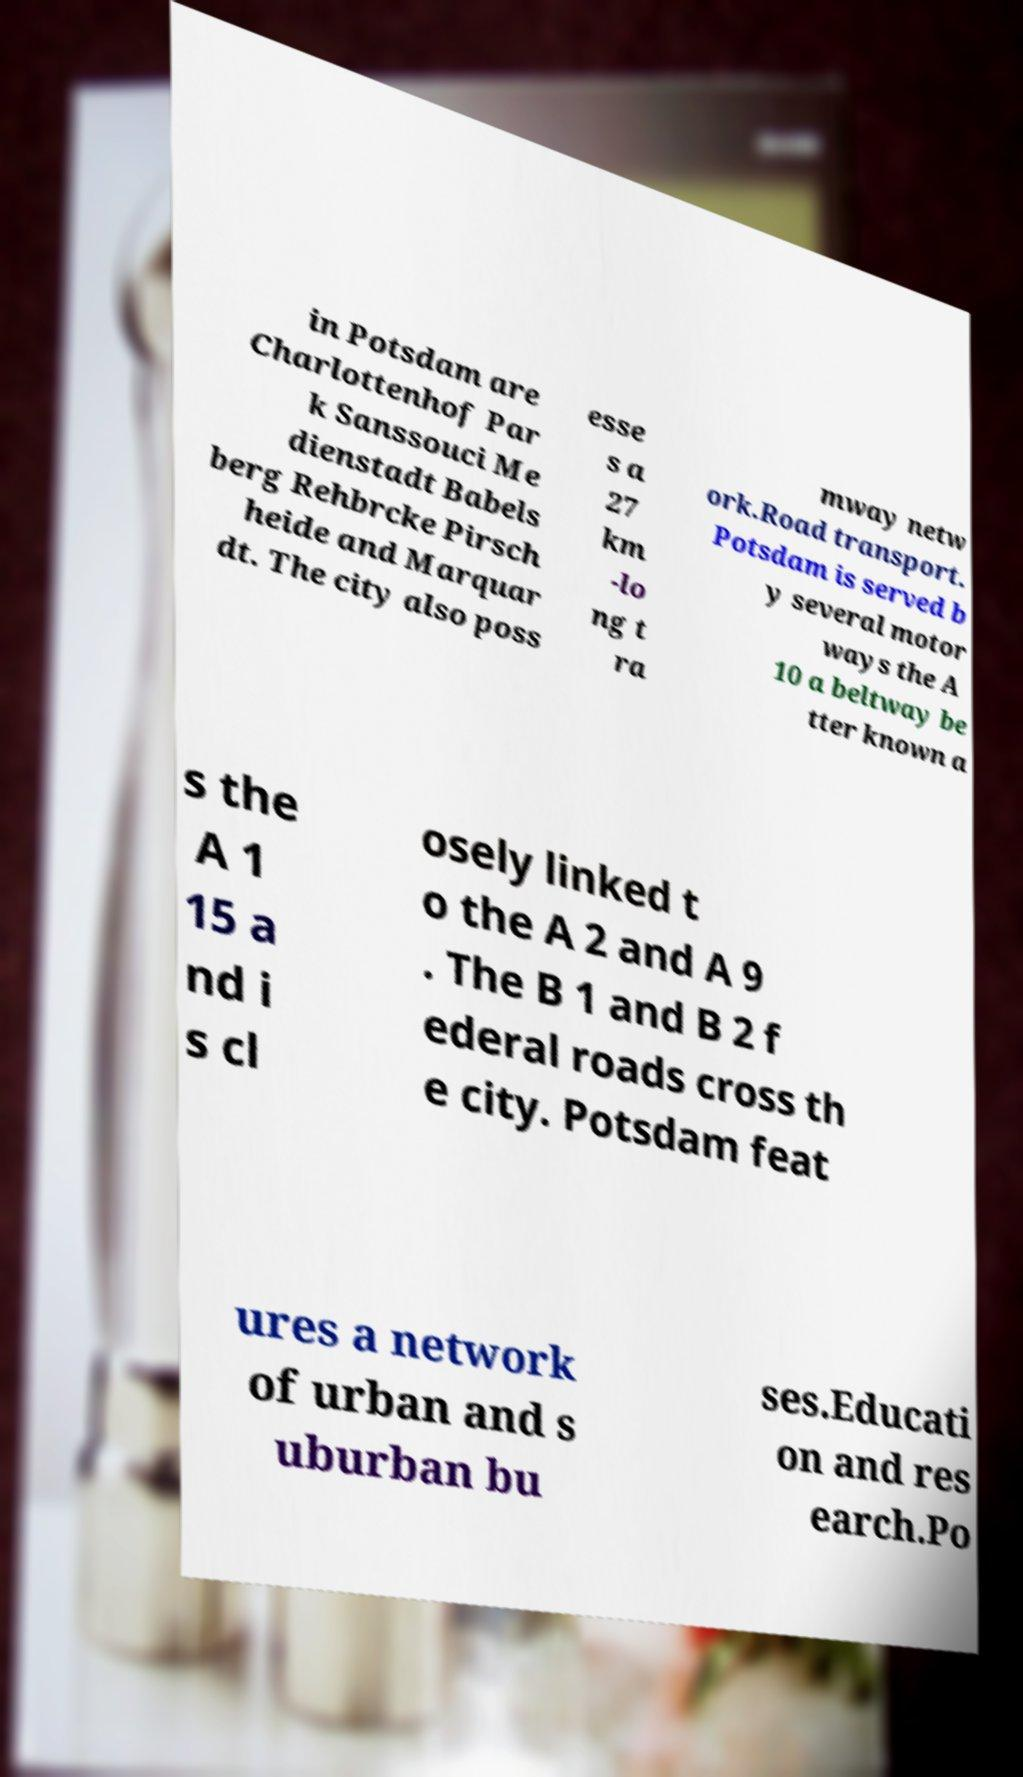Please read and relay the text visible in this image. What does it say? in Potsdam are Charlottenhof Par k Sanssouci Me dienstadt Babels berg Rehbrcke Pirsch heide and Marquar dt. The city also poss esse s a 27 km -lo ng t ra mway netw ork.Road transport. Potsdam is served b y several motor ways the A 10 a beltway be tter known a s the A 1 15 a nd i s cl osely linked t o the A 2 and A 9 . The B 1 and B 2 f ederal roads cross th e city. Potsdam feat ures a network of urban and s uburban bu ses.Educati on and res earch.Po 